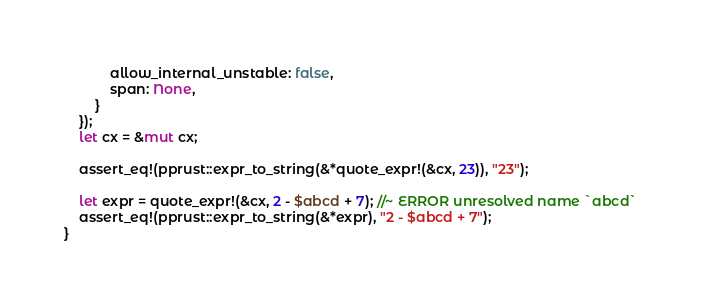<code> <loc_0><loc_0><loc_500><loc_500><_Rust_>            allow_internal_unstable: false,
            span: None,
        }
    });
    let cx = &mut cx;

    assert_eq!(pprust::expr_to_string(&*quote_expr!(&cx, 23)), "23");

    let expr = quote_expr!(&cx, 2 - $abcd + 7); //~ ERROR unresolved name `abcd`
    assert_eq!(pprust::expr_to_string(&*expr), "2 - $abcd + 7");
}
</code> 